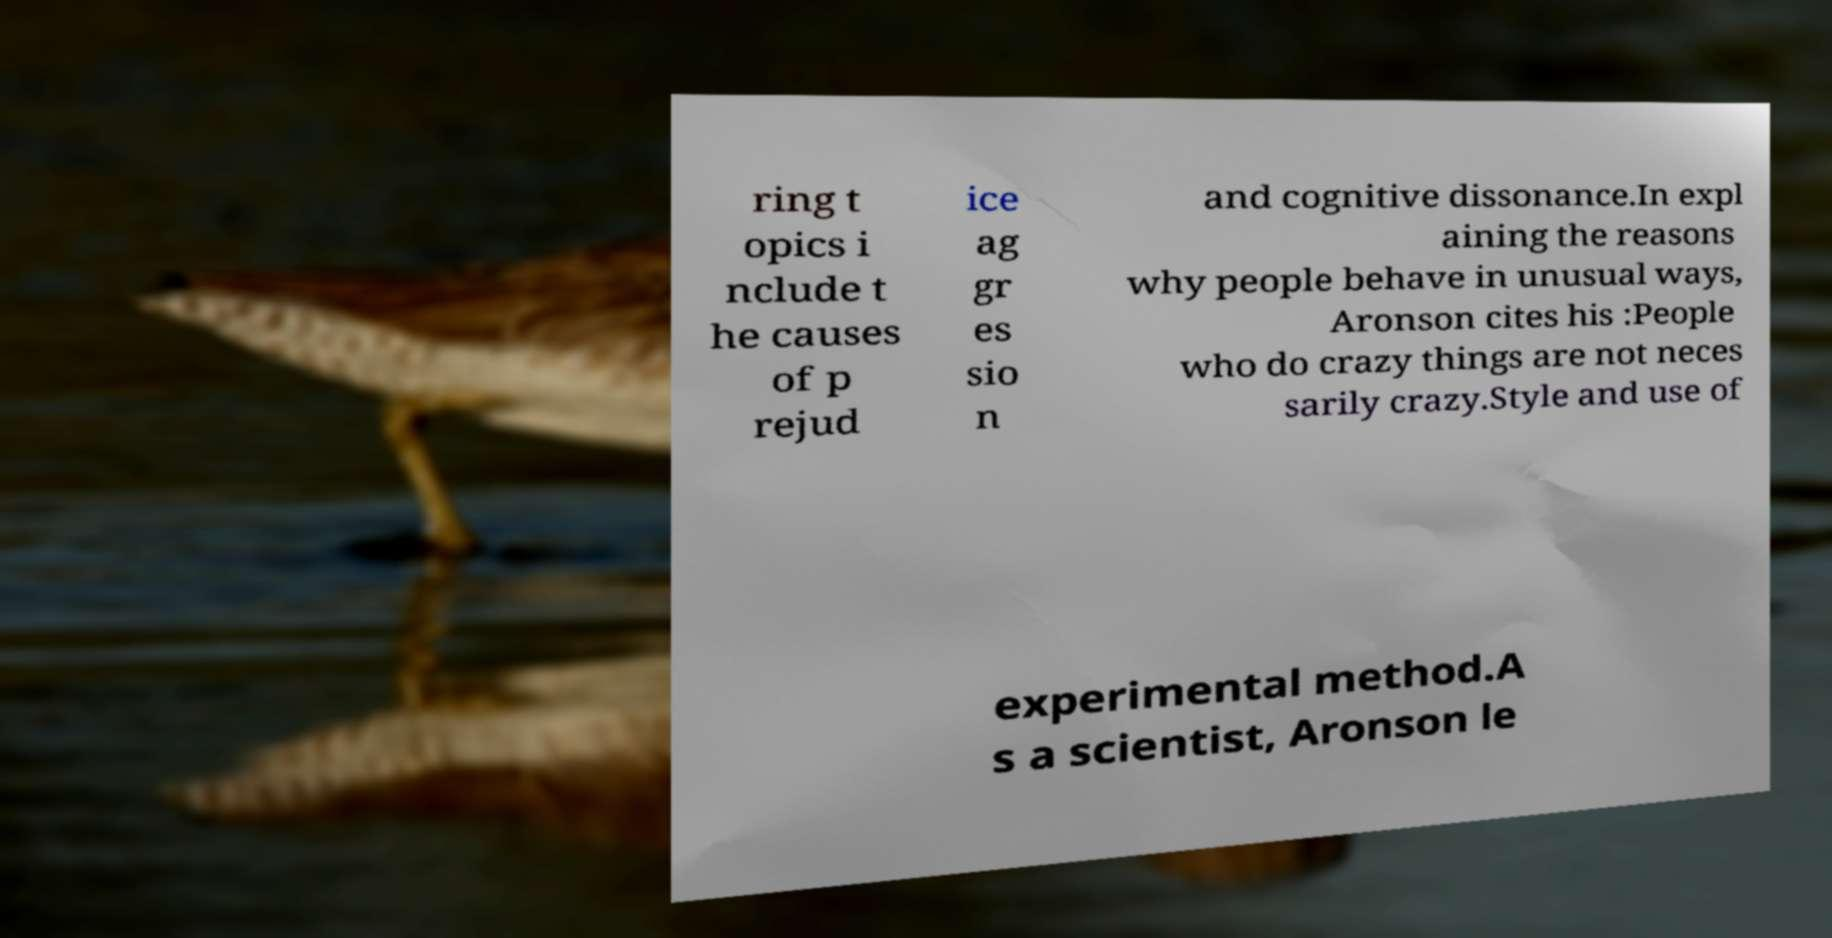Please read and relay the text visible in this image. What does it say? ring t opics i nclude t he causes of p rejud ice ag gr es sio n and cognitive dissonance.In expl aining the reasons why people behave in unusual ways, Aronson cites his :People who do crazy things are not neces sarily crazy.Style and use of experimental method.A s a scientist, Aronson le 